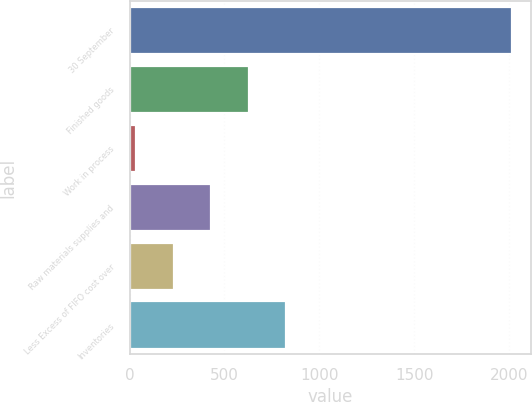<chart> <loc_0><loc_0><loc_500><loc_500><bar_chart><fcel>30 September<fcel>Finished goods<fcel>Work in process<fcel>Raw materials supplies and<fcel>Less Excess of FIFO cost over<fcel>Inventories<nl><fcel>2015<fcel>628.58<fcel>34.4<fcel>430.52<fcel>232.46<fcel>826.64<nl></chart> 